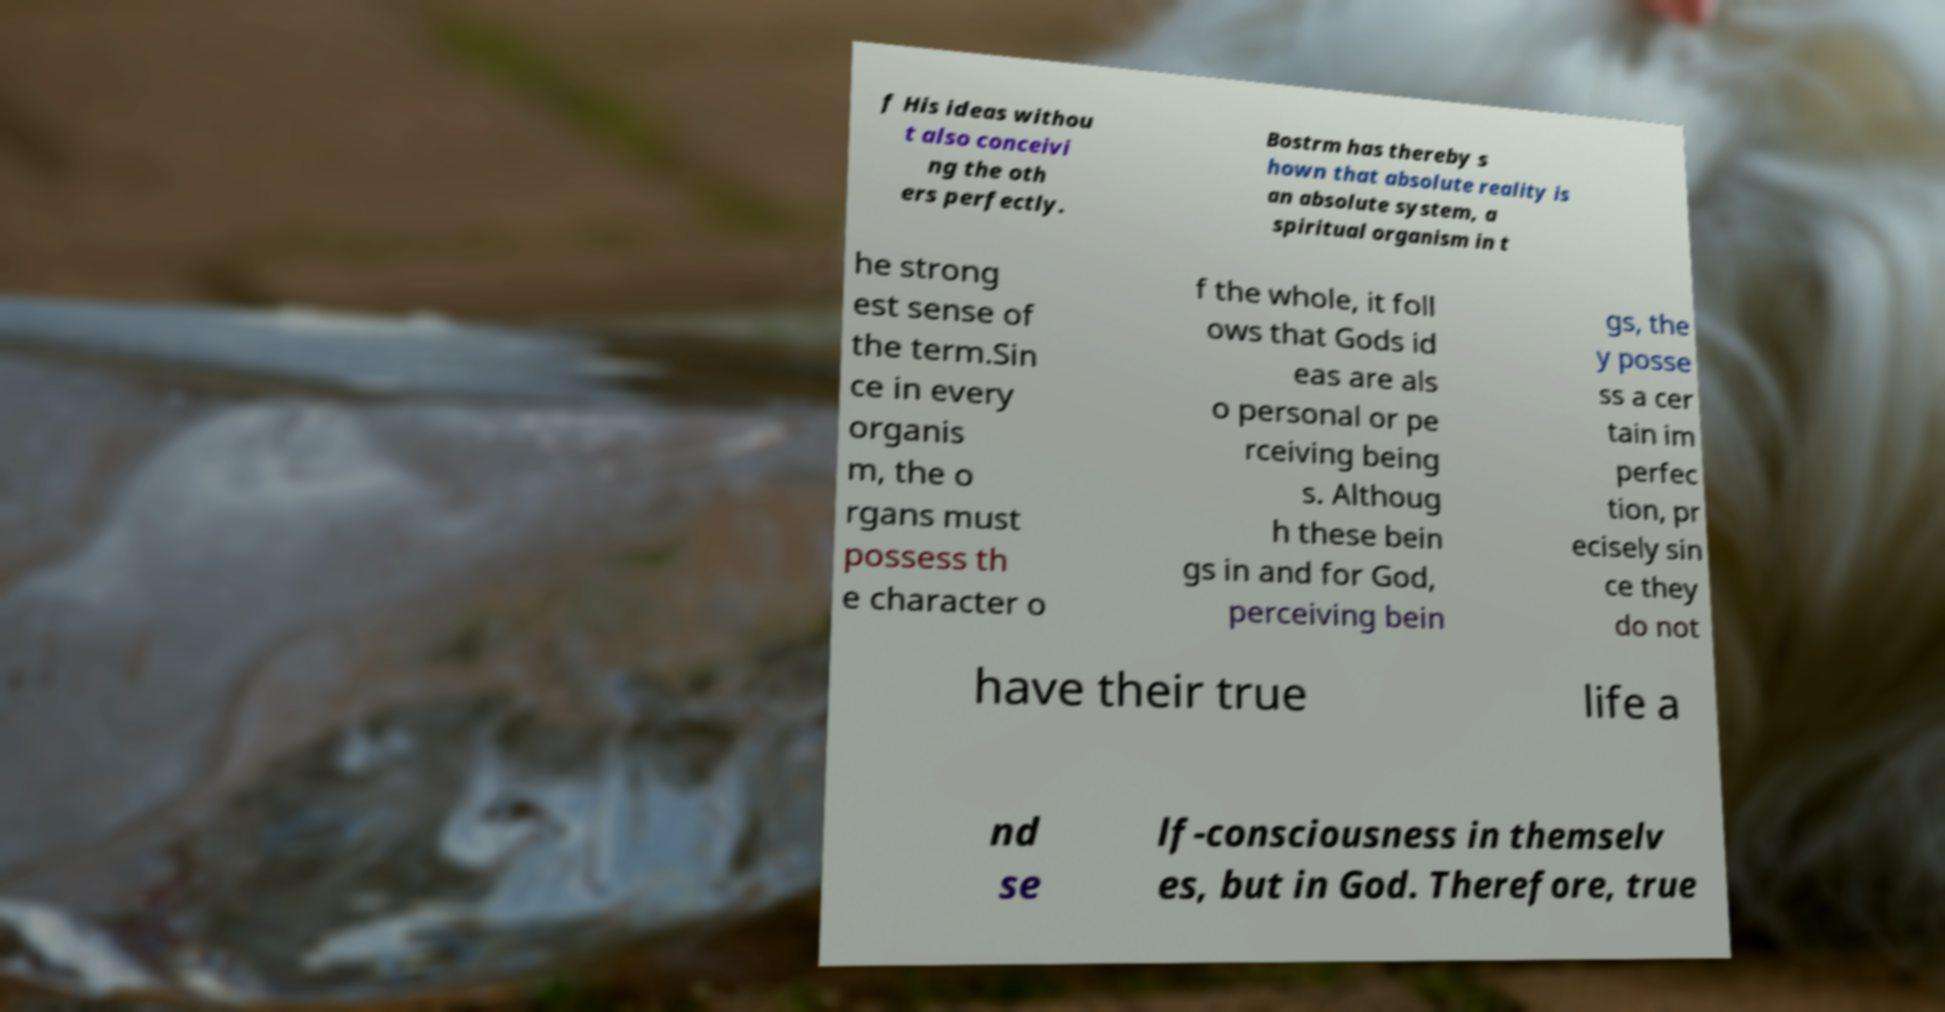Could you extract and type out the text from this image? f His ideas withou t also conceivi ng the oth ers perfectly. Bostrm has thereby s hown that absolute reality is an absolute system, a spiritual organism in t he strong est sense of the term.Sin ce in every organis m, the o rgans must possess th e character o f the whole, it foll ows that Gods id eas are als o personal or pe rceiving being s. Althoug h these bein gs in and for God, perceiving bein gs, the y posse ss a cer tain im perfec tion, pr ecisely sin ce they do not have their true life a nd se lf-consciousness in themselv es, but in God. Therefore, true 